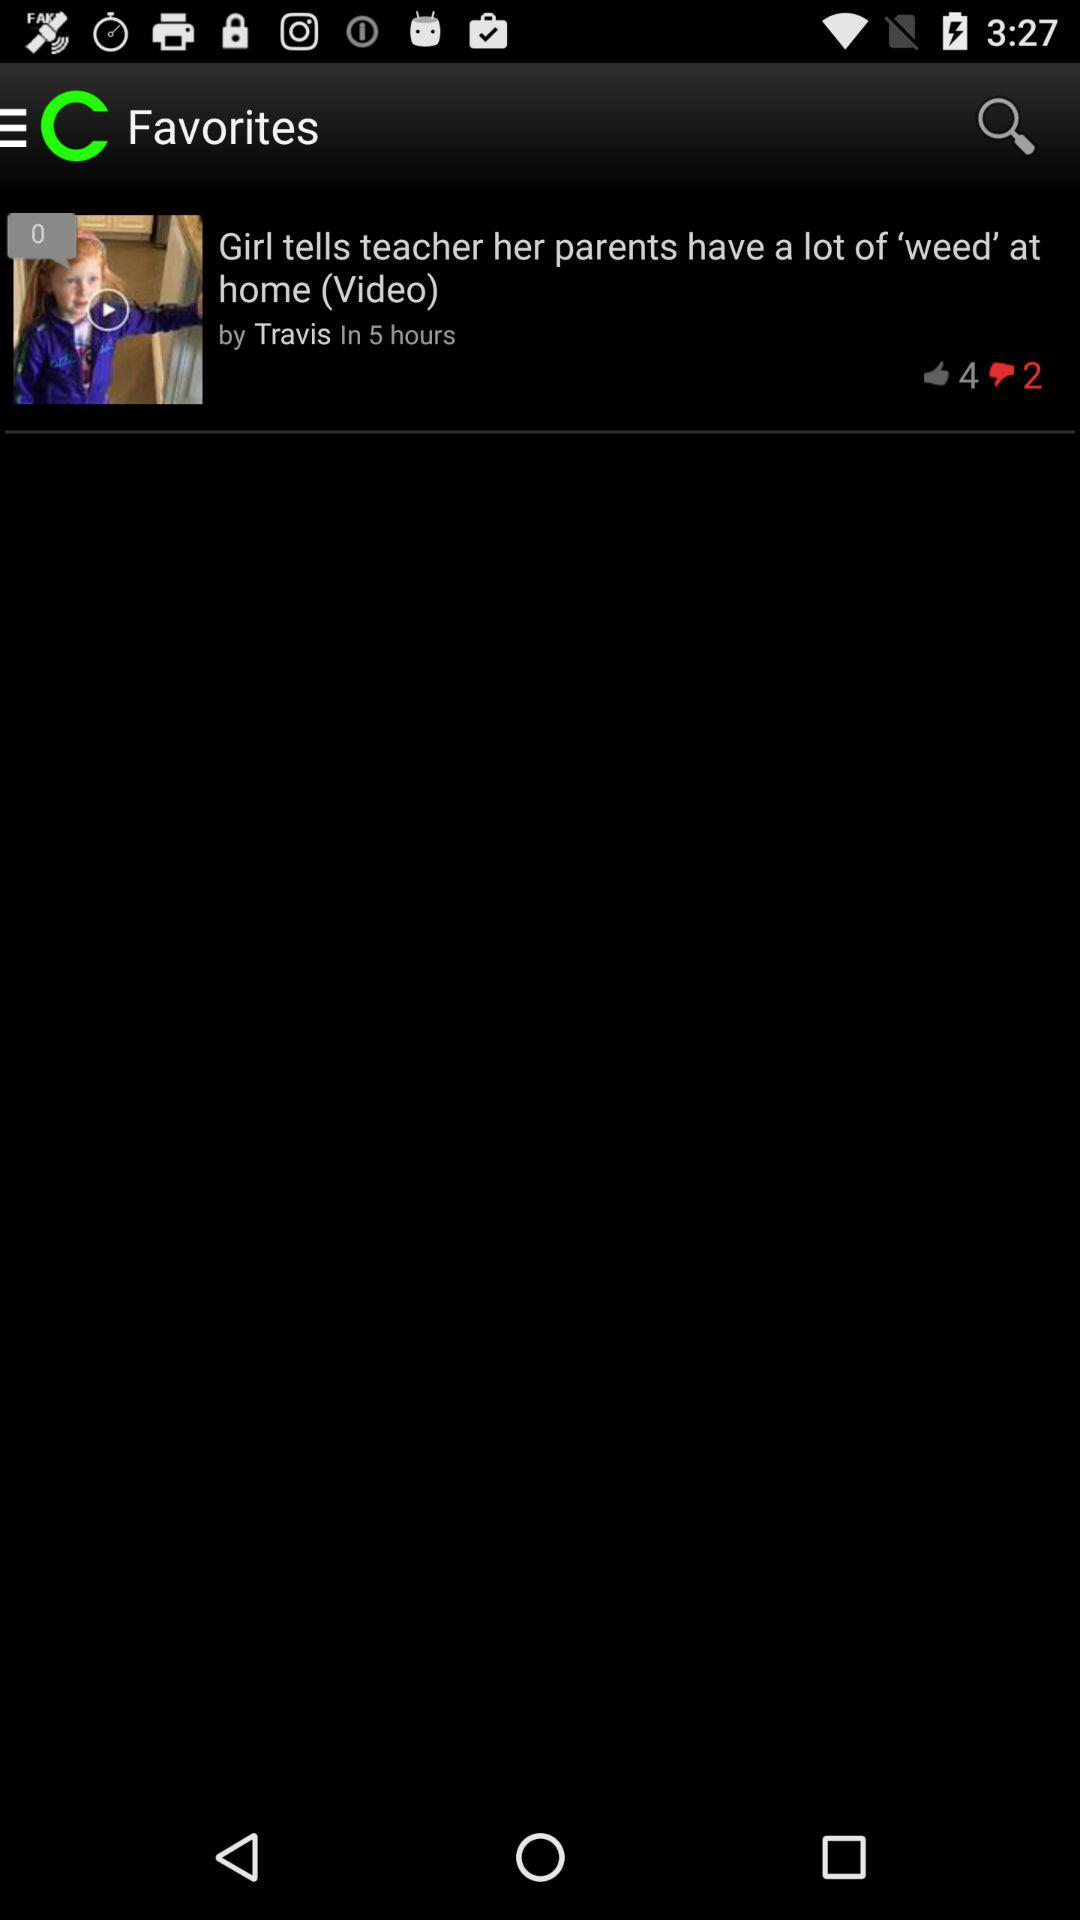How many hours ago was the video uploaded? The video was uploaded 5 hours ago. 